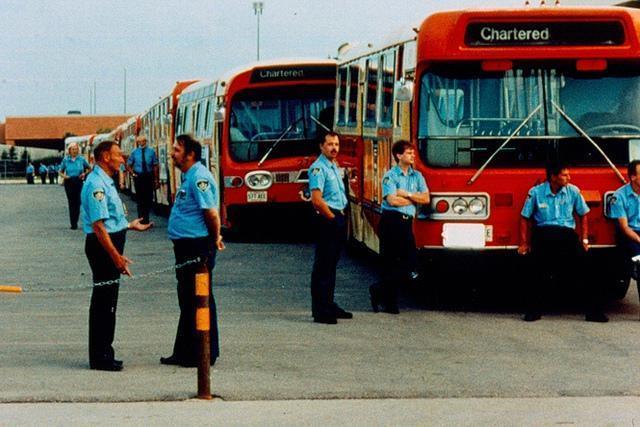How many people can be seen?
Give a very brief answer. 6. How many buses are in the picture?
Give a very brief answer. 3. How many sheep are facing forward?
Give a very brief answer. 0. 